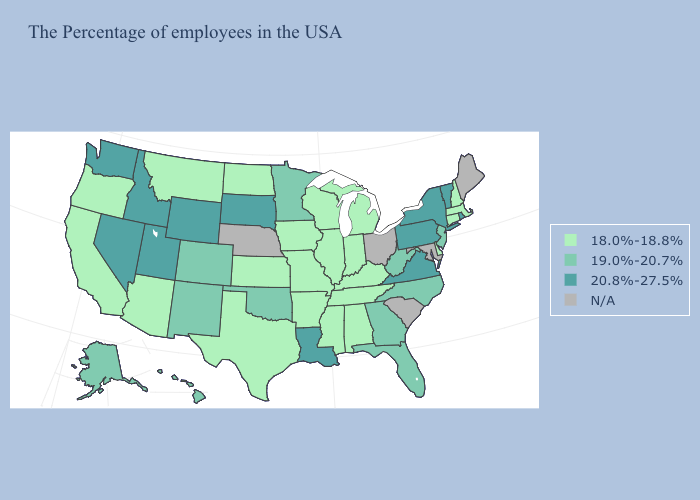What is the value of West Virginia?
Give a very brief answer. 19.0%-20.7%. What is the highest value in the MidWest ?
Short answer required. 20.8%-27.5%. Among the states that border Nevada , does Idaho have the lowest value?
Concise answer only. No. Name the states that have a value in the range 20.8%-27.5%?
Concise answer only. Rhode Island, Vermont, New York, Pennsylvania, Virginia, Louisiana, South Dakota, Wyoming, Utah, Idaho, Nevada, Washington. Which states have the lowest value in the USA?
Answer briefly. Massachusetts, New Hampshire, Connecticut, Delaware, Michigan, Kentucky, Indiana, Alabama, Tennessee, Wisconsin, Illinois, Mississippi, Missouri, Arkansas, Iowa, Kansas, Texas, North Dakota, Montana, Arizona, California, Oregon. Does Rhode Island have the highest value in the USA?
Short answer required. Yes. Name the states that have a value in the range N/A?
Answer briefly. Maine, Maryland, South Carolina, Ohio, Nebraska. What is the lowest value in the MidWest?
Give a very brief answer. 18.0%-18.8%. What is the value of California?
Concise answer only. 18.0%-18.8%. Name the states that have a value in the range 18.0%-18.8%?
Concise answer only. Massachusetts, New Hampshire, Connecticut, Delaware, Michigan, Kentucky, Indiana, Alabama, Tennessee, Wisconsin, Illinois, Mississippi, Missouri, Arkansas, Iowa, Kansas, Texas, North Dakota, Montana, Arizona, California, Oregon. Does Iowa have the lowest value in the MidWest?
Keep it brief. Yes. Name the states that have a value in the range 20.8%-27.5%?
Concise answer only. Rhode Island, Vermont, New York, Pennsylvania, Virginia, Louisiana, South Dakota, Wyoming, Utah, Idaho, Nevada, Washington. What is the lowest value in the USA?
Give a very brief answer. 18.0%-18.8%. 